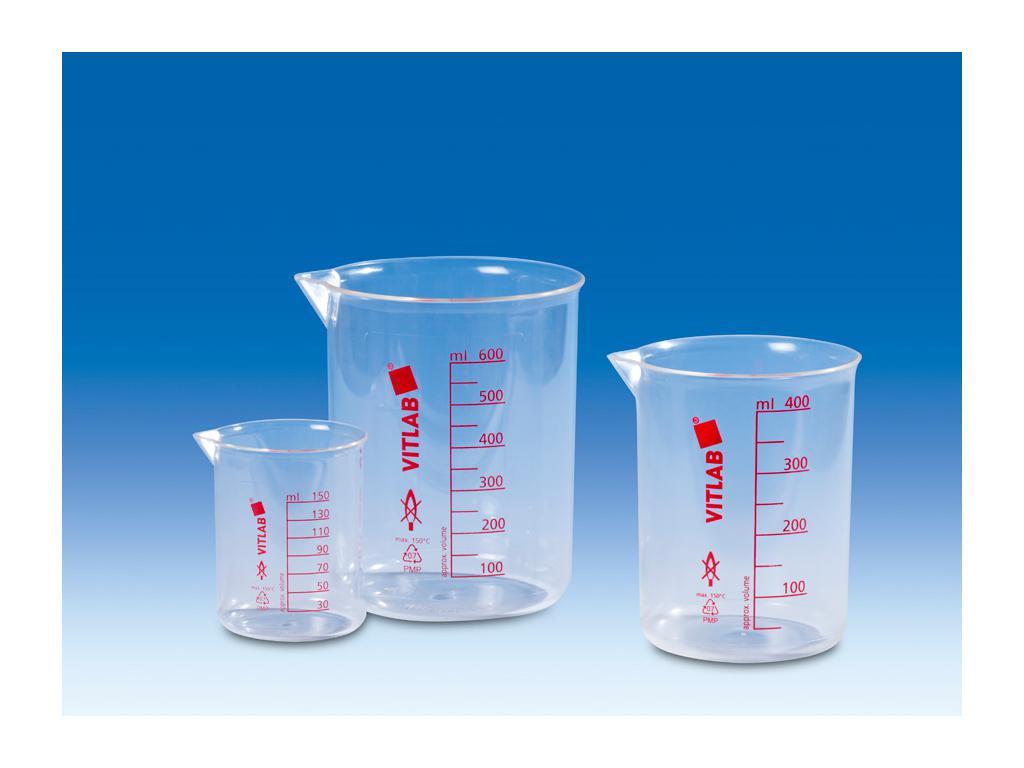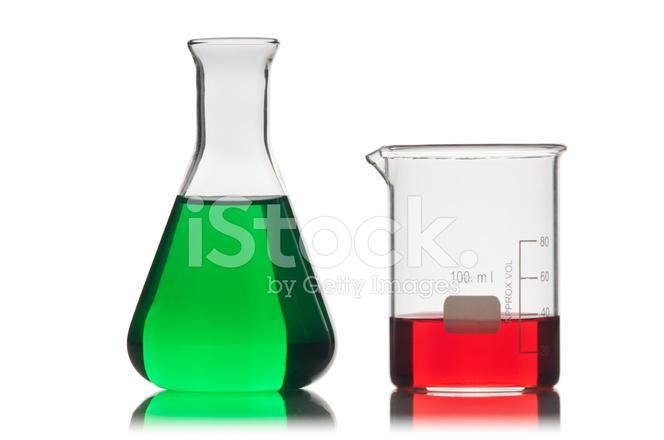The first image is the image on the left, the second image is the image on the right. Evaluate the accuracy of this statement regarding the images: "In one image, there is one beaker with a green liquid and one beaker with a red liquid". Is it true? Answer yes or no. Yes. The first image is the image on the left, the second image is the image on the right. Considering the images on both sides, is "One image shows beakers filled with at least three different colors of liquid." valid? Answer yes or no. No. 